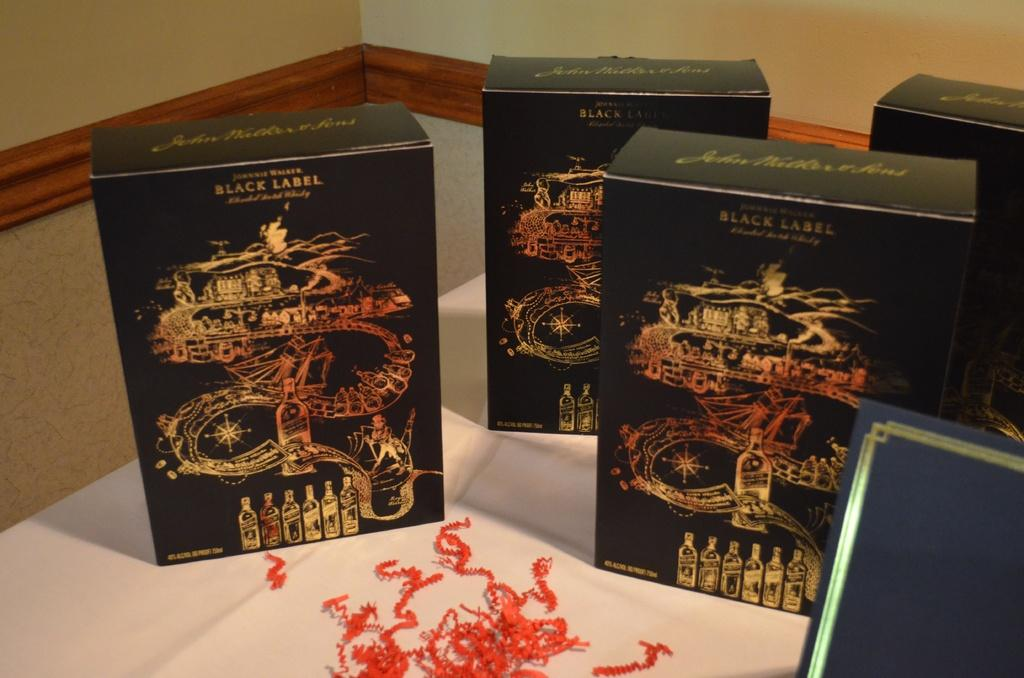<image>
Summarize the visual content of the image. Some boxes of Johnnie Walker Black Label sit on a table along with some strings of red confetti. 